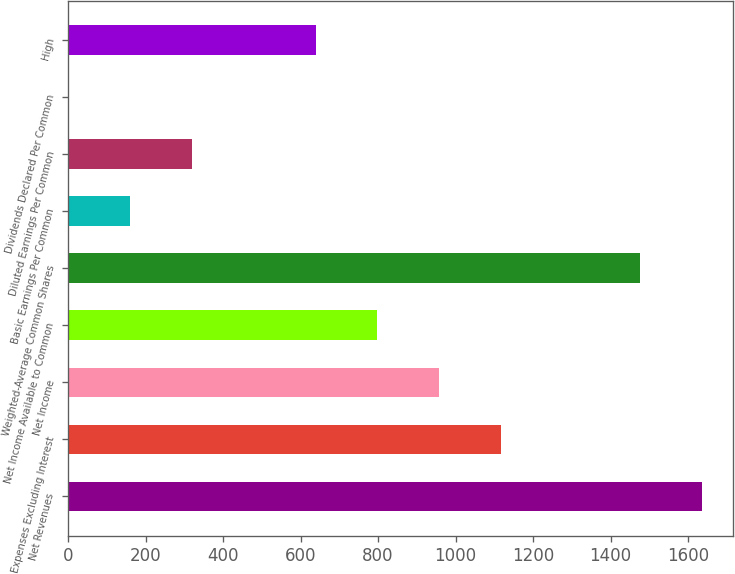<chart> <loc_0><loc_0><loc_500><loc_500><bar_chart><fcel>Net Revenues<fcel>Expenses Excluding Interest<fcel>Net Income<fcel>Net Income Available to Common<fcel>Weighted-Average Common Shares<fcel>Basic Earnings Per Common<fcel>Diluted Earnings Per Common<fcel>Dividends Declared Per Common<fcel>High<nl><fcel>1635.38<fcel>1117.89<fcel>958.2<fcel>798.51<fcel>1475.69<fcel>159.75<fcel>319.44<fcel>0.06<fcel>638.82<nl></chart> 